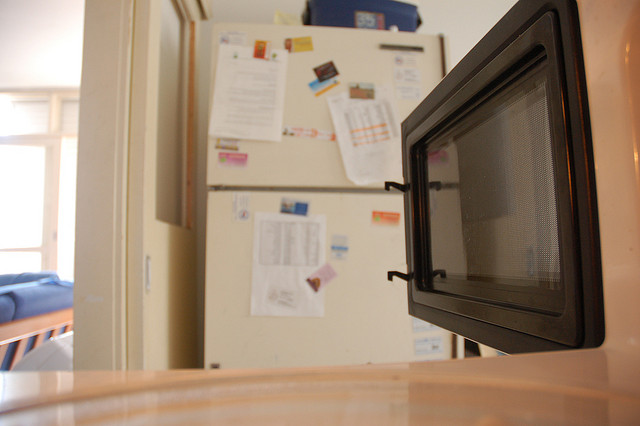<image>Is the giraffe inside or outside? There is no giraffe in the image. However, if it was, it could be either inside or outside. What are the 2 black knobs for? I am not sure what the 2 black knobs are for. They can be for control, latch or lock door. Is the giraffe inside or outside? It is ambiguous whether the giraffe is inside or outside. What are the 2 black knobs for? It is ambiguous what the 2 black knobs are for. They can be used to control or latch the door. 